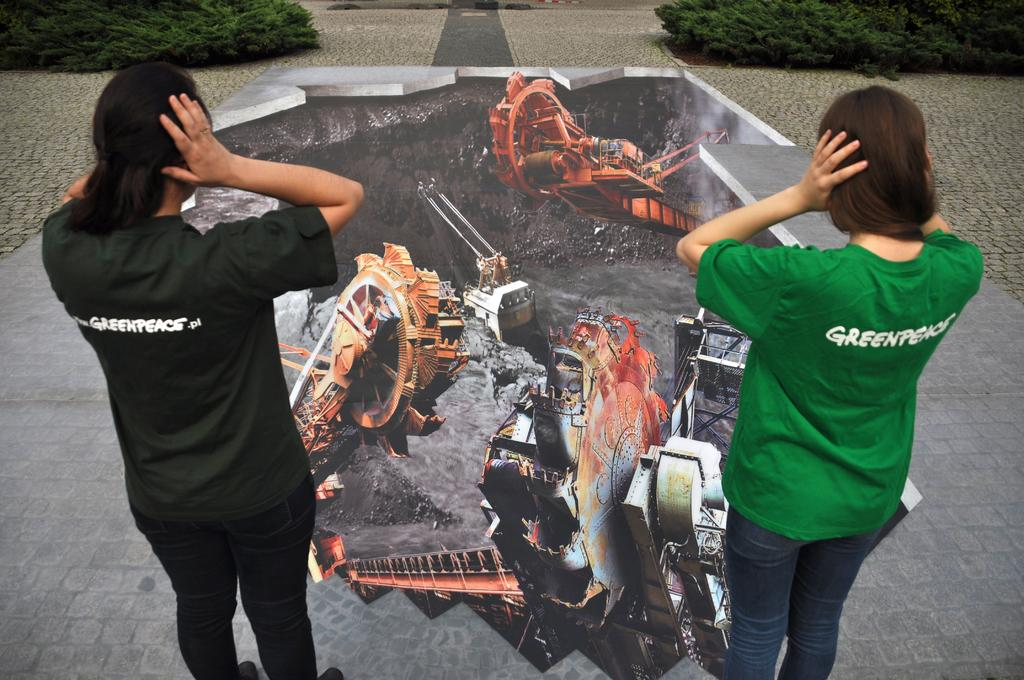<image>
Present a compact description of the photo's key features. Two people with t-shirts saying "Greenpeace" standing in front of a drawing covering their ears. 